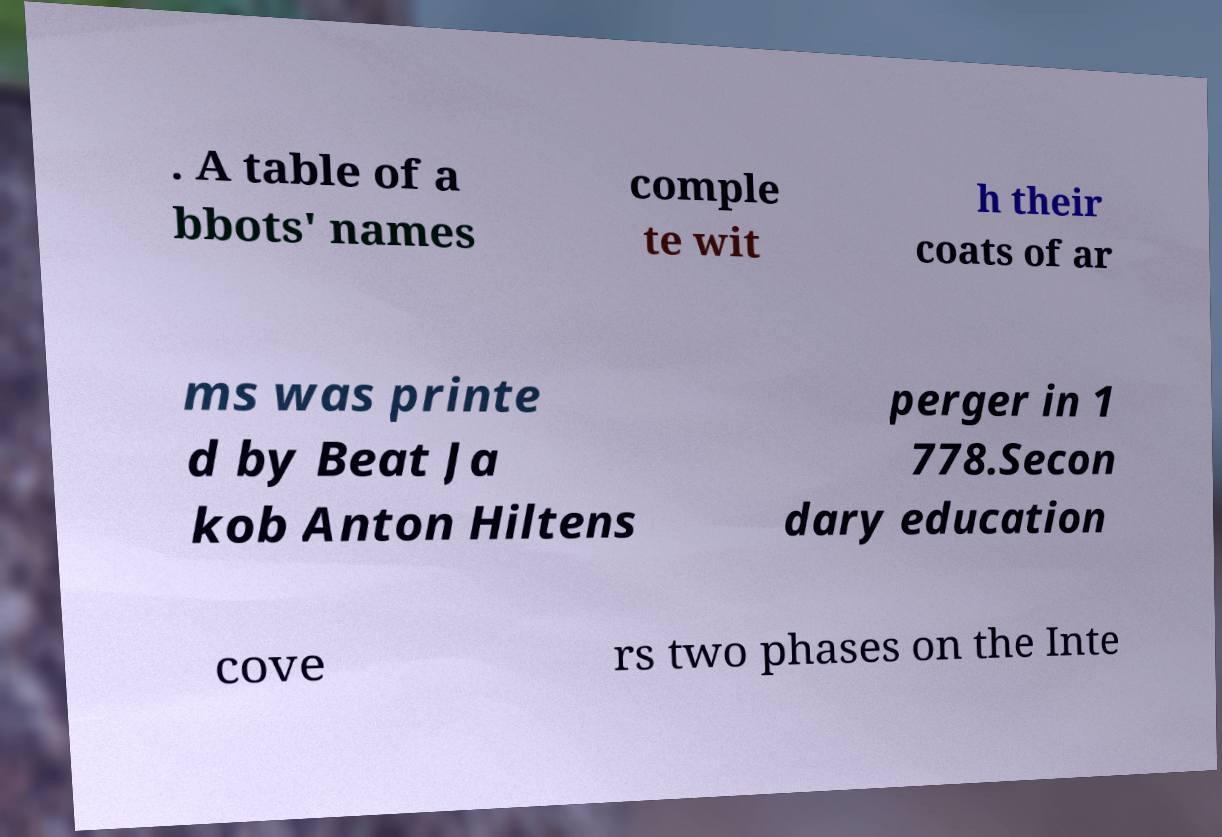What messages or text are displayed in this image? I need them in a readable, typed format. . A table of a bbots' names comple te wit h their coats of ar ms was printe d by Beat Ja kob Anton Hiltens perger in 1 778.Secon dary education cove rs two phases on the Inte 